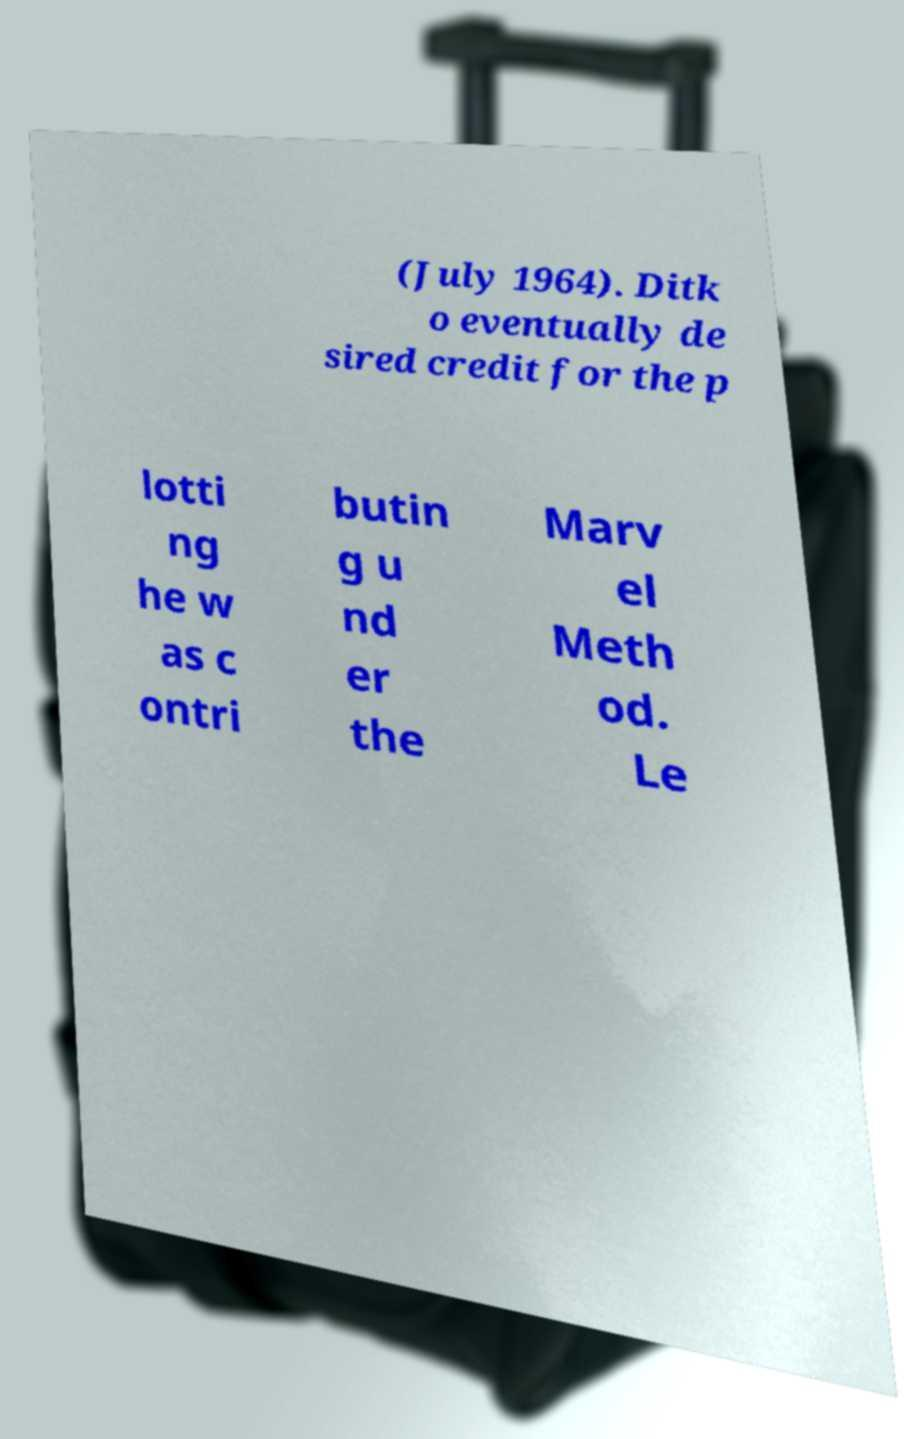Can you accurately transcribe the text from the provided image for me? (July 1964). Ditk o eventually de sired credit for the p lotti ng he w as c ontri butin g u nd er the Marv el Meth od. Le 